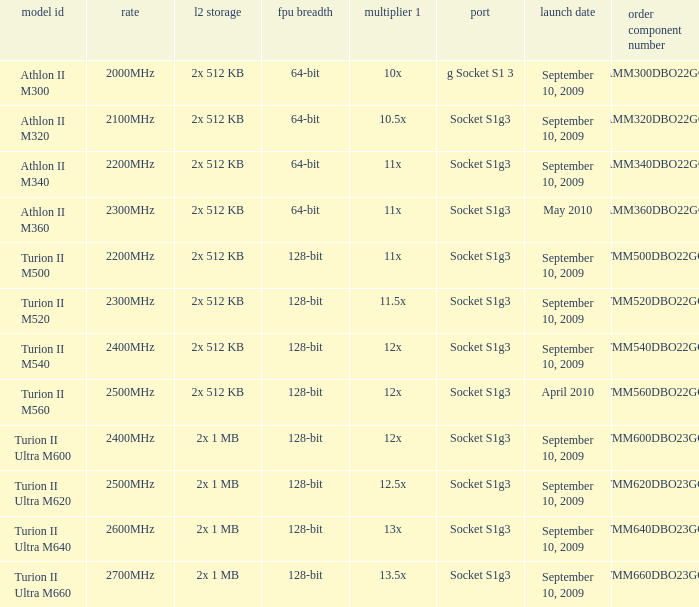What is the release date of the 2x 512 kb L2 cache with a 11x multi 1, and a FPU width of 128-bit? September 10, 2009. 